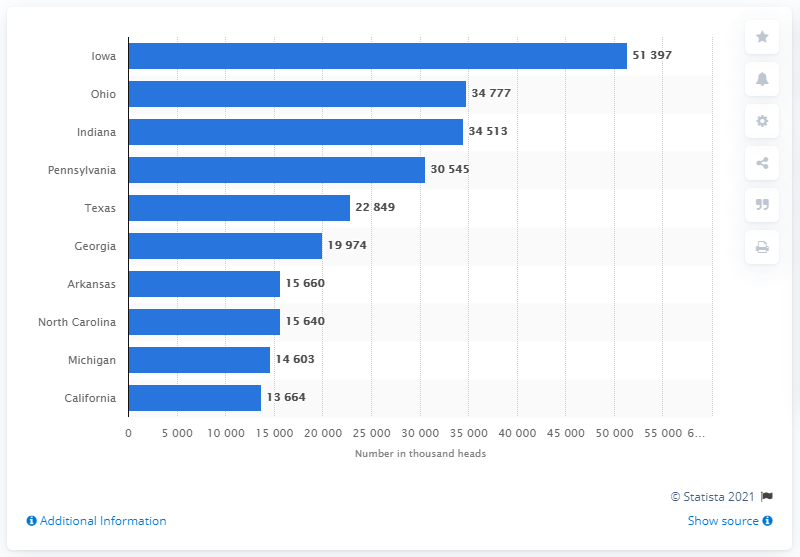List a handful of essential elements in this visual. In 2020, the state with the highest number of laying hens was Iowa. 